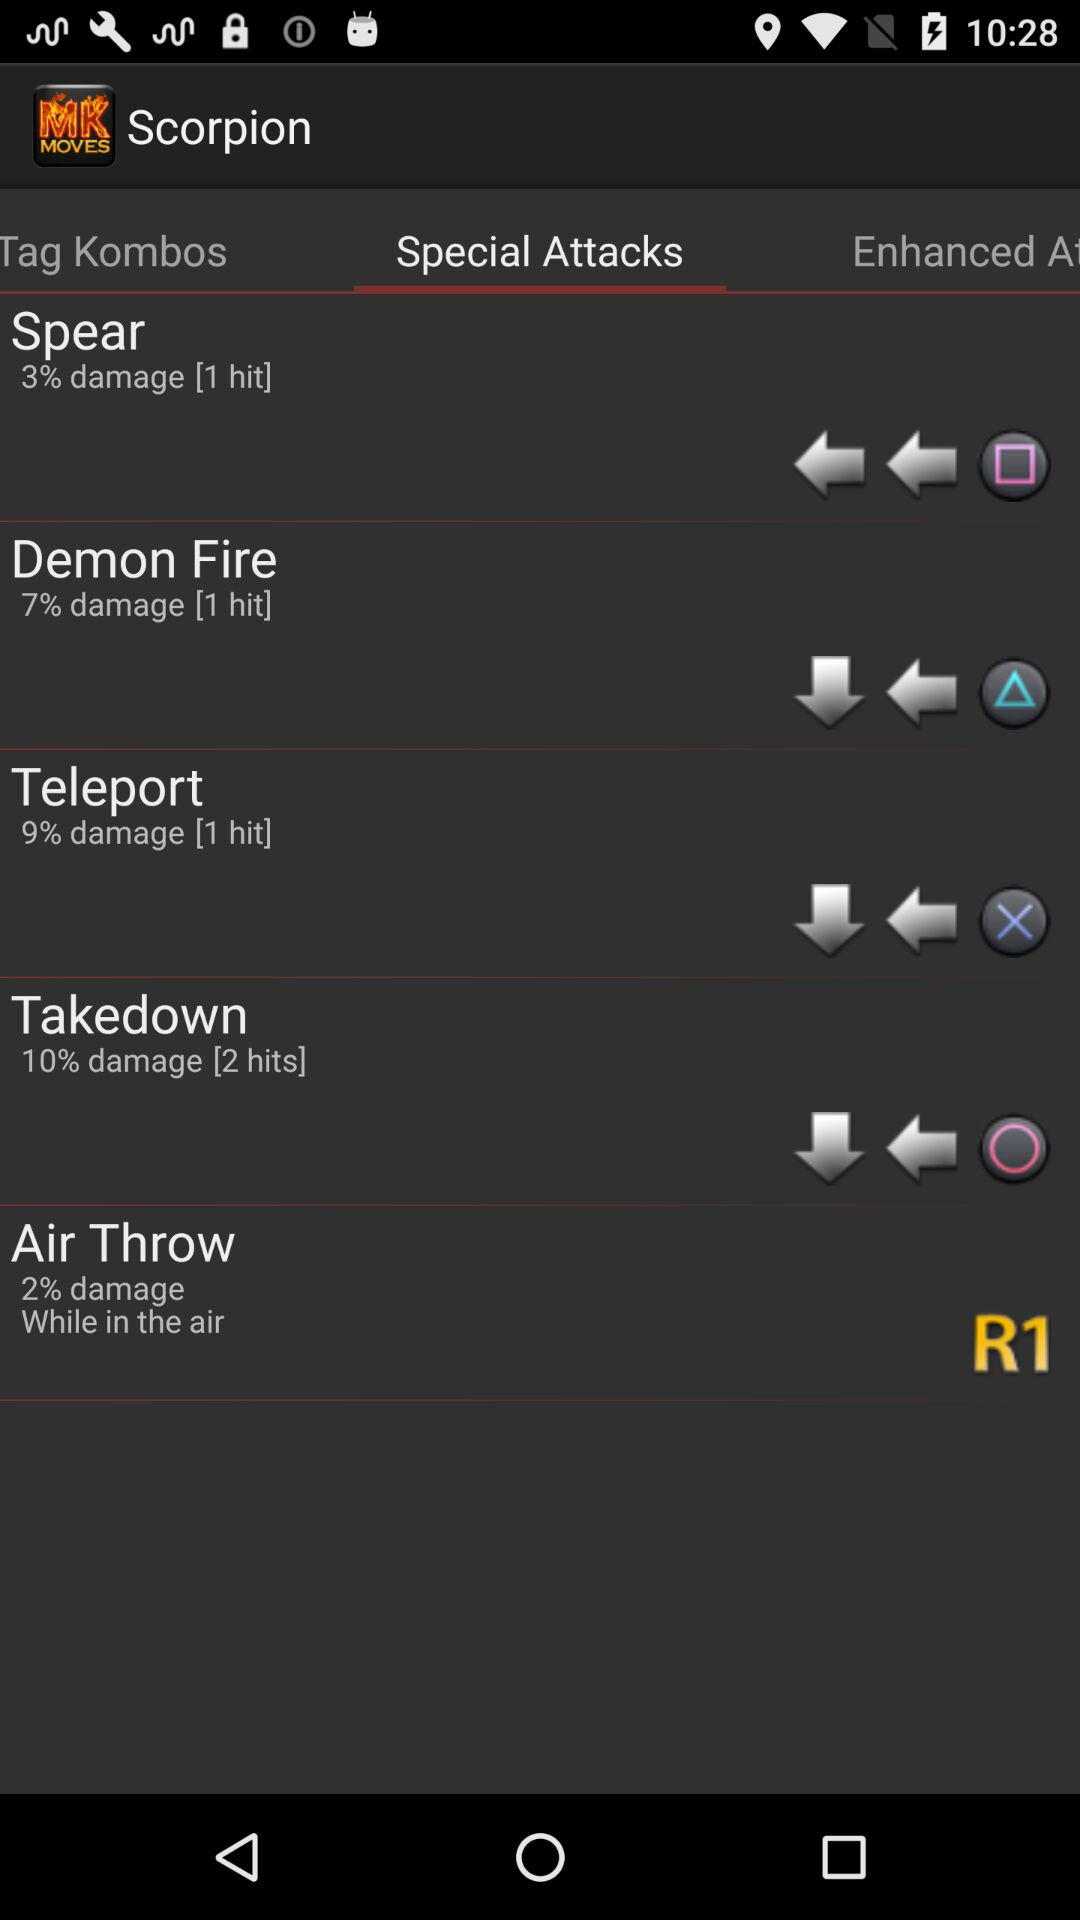Which tab has been selected? The selected tab is "Special Attacks". 